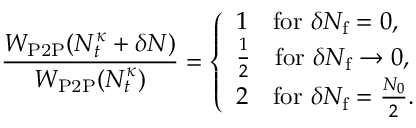<formula> <loc_0><loc_0><loc_500><loc_500>\frac { W _ { P 2 P } ( N _ { t } ^ { \kappa } + \delta N ) } { W _ { P 2 P } ( N _ { t } ^ { \kappa } ) } = \left \{ \begin{array} { l l } { 1 \quad f o r \delta N _ { f } = 0 , } \\ { \frac { 1 } { 2 } \quad f o r \delta N _ { f } \to 0 , } \\ { 2 \quad f o r \delta N _ { f } = \frac { N _ { 0 } } { 2 } . } \end{array}</formula> 